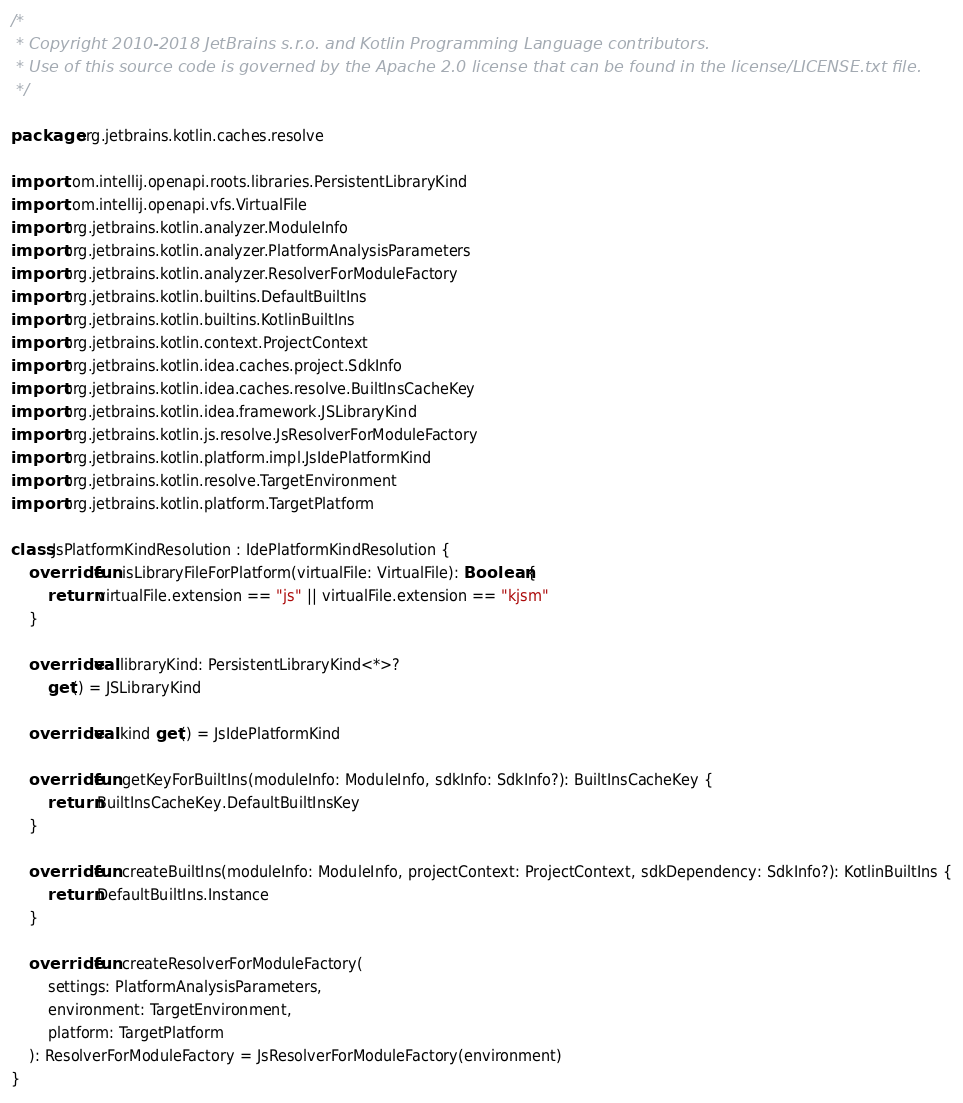<code> <loc_0><loc_0><loc_500><loc_500><_Kotlin_>/*
 * Copyright 2010-2018 JetBrains s.r.o. and Kotlin Programming Language contributors.
 * Use of this source code is governed by the Apache 2.0 license that can be found in the license/LICENSE.txt file.
 */

package org.jetbrains.kotlin.caches.resolve

import com.intellij.openapi.roots.libraries.PersistentLibraryKind
import com.intellij.openapi.vfs.VirtualFile
import org.jetbrains.kotlin.analyzer.ModuleInfo
import org.jetbrains.kotlin.analyzer.PlatformAnalysisParameters
import org.jetbrains.kotlin.analyzer.ResolverForModuleFactory
import org.jetbrains.kotlin.builtins.DefaultBuiltIns
import org.jetbrains.kotlin.builtins.KotlinBuiltIns
import org.jetbrains.kotlin.context.ProjectContext
import org.jetbrains.kotlin.idea.caches.project.SdkInfo
import org.jetbrains.kotlin.idea.caches.resolve.BuiltInsCacheKey
import org.jetbrains.kotlin.idea.framework.JSLibraryKind
import org.jetbrains.kotlin.js.resolve.JsResolverForModuleFactory
import org.jetbrains.kotlin.platform.impl.JsIdePlatformKind
import org.jetbrains.kotlin.resolve.TargetEnvironment
import org.jetbrains.kotlin.platform.TargetPlatform

class JsPlatformKindResolution : IdePlatformKindResolution {
    override fun isLibraryFileForPlatform(virtualFile: VirtualFile): Boolean {
        return virtualFile.extension == "js" || virtualFile.extension == "kjsm"
    }

    override val libraryKind: PersistentLibraryKind<*>?
        get() = JSLibraryKind

    override val kind get() = JsIdePlatformKind

    override fun getKeyForBuiltIns(moduleInfo: ModuleInfo, sdkInfo: SdkInfo?): BuiltInsCacheKey {
        return BuiltInsCacheKey.DefaultBuiltInsKey
    }

    override fun createBuiltIns(moduleInfo: ModuleInfo, projectContext: ProjectContext, sdkDependency: SdkInfo?): KotlinBuiltIns {
        return DefaultBuiltIns.Instance
    }

    override fun createResolverForModuleFactory(
        settings: PlatformAnalysisParameters,
        environment: TargetEnvironment,
        platform: TargetPlatform
    ): ResolverForModuleFactory = JsResolverForModuleFactory(environment)
}
</code> 